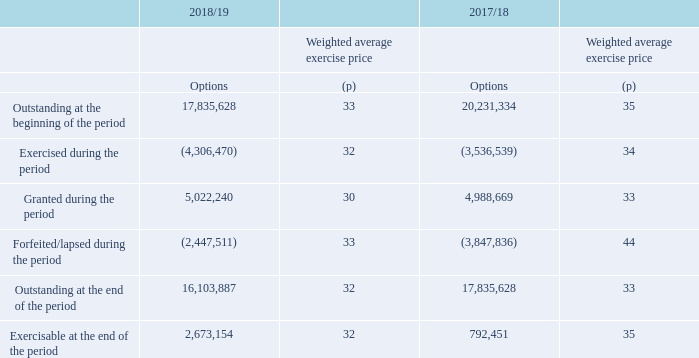During the period 5.0 million (2017/18: 5.0 million) options were granted under the Sharesave Plan, with a weighted average exercise price at the date of exercise of 30 pence per ordinary share (2017/18: 33 pence).
The options outstanding at 30 March 2019 had a weighted average exercise price of 32 pence (2017/18: 33 pence), and a weighted average remaining contractual life of 1.6 years (2017/18: 1.6 years).
In 2018/19, the Group recognised an expense of £2.1m (2017/18: £2.8m), related to all equity-settled share-based payment transactions.
Premier Foods plc Sharesave Plan
What was the amount of options granted under the Sharesave plan? 5.0 million. What was the weighted average exercise price of outstanding options at 30 March 2019? 32 pence. What was the expense recognised in 2018/19? £2.1m. What was the change in the Outstanding at the beginning of the period for options from 2017/18 to 2018/19? 17,835,628 - 20,231,334
Answer: -2395706. What is the change in the Exercised during the period weighted average exercise price from 2017/18 to 2018/19? 32 - 34
Answer: -2. What is the change in options granted between 2017/18 and 2018/19? 5,022,240 - 4,988,669
Answer: 33571. 